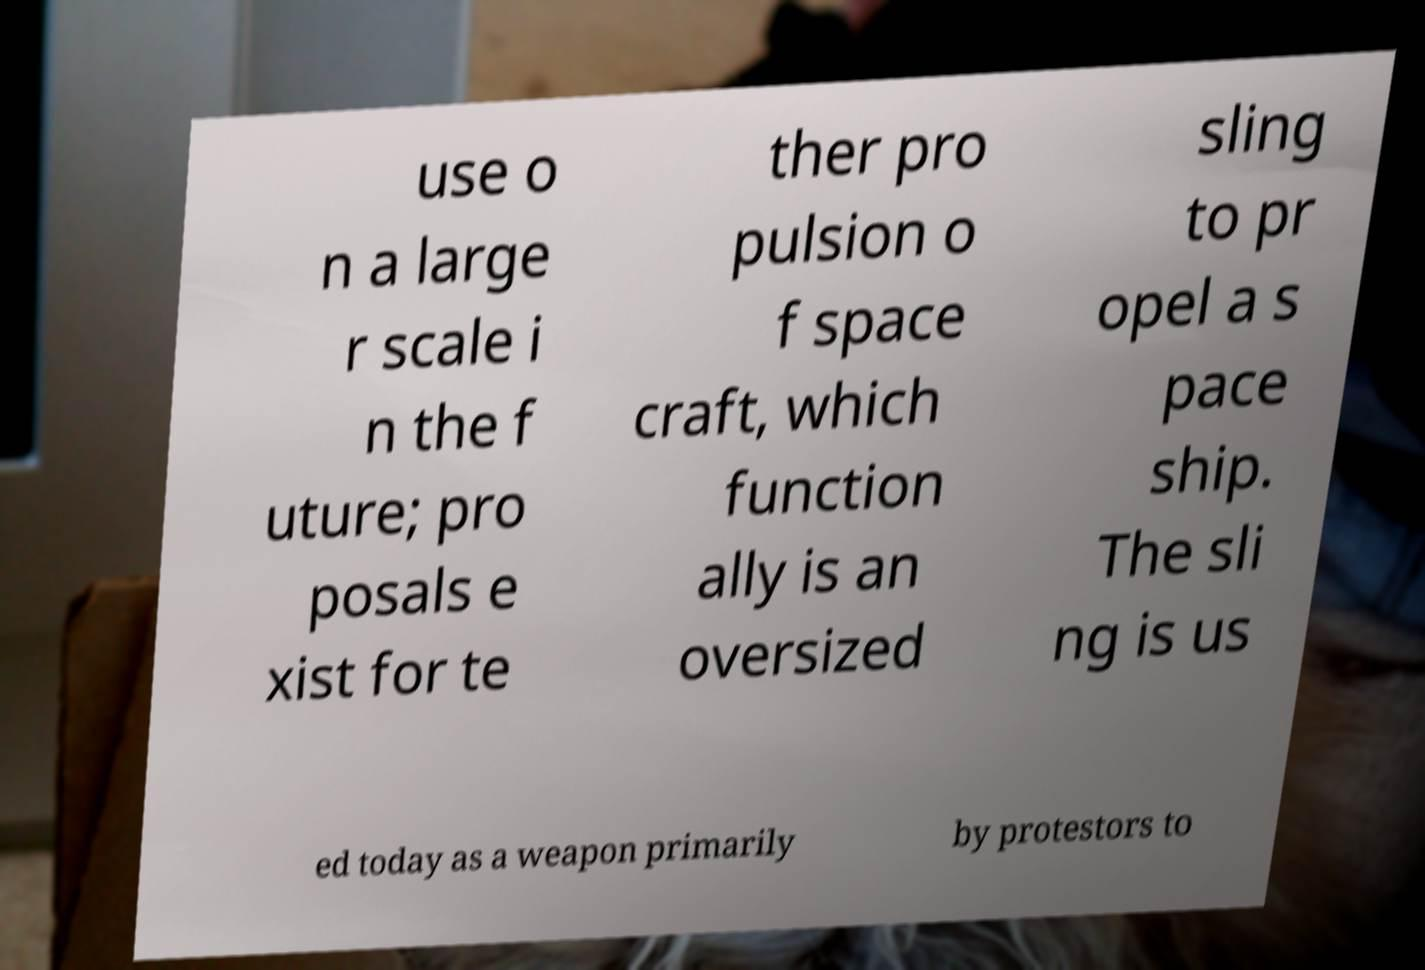There's text embedded in this image that I need extracted. Can you transcribe it verbatim? use o n a large r scale i n the f uture; pro posals e xist for te ther pro pulsion o f space craft, which function ally is an oversized sling to pr opel a s pace ship. The sli ng is us ed today as a weapon primarily by protestors to 